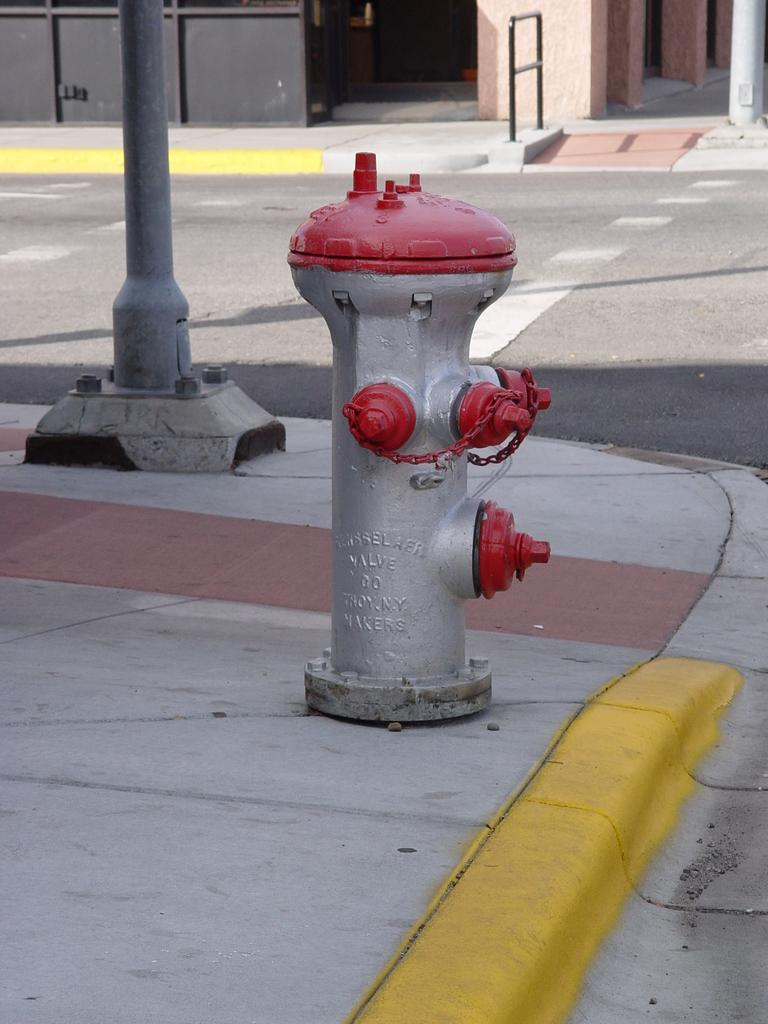What object can be seen on the sidewalk in the image? There is a pole on the sidewalk in the image. What is located near the pole on the sidewalk? There is a fire hydrant in the image. What can be seen in the background of the image? There appears to be a building in the background of the image. What type of maid is featured in the image? There is no maid present in the image. What is the plot of the story unfolding in the image? There is no story or plot depicted in the image; it simply shows a fire hydrant and a pole on the sidewalk with a building in the background. 